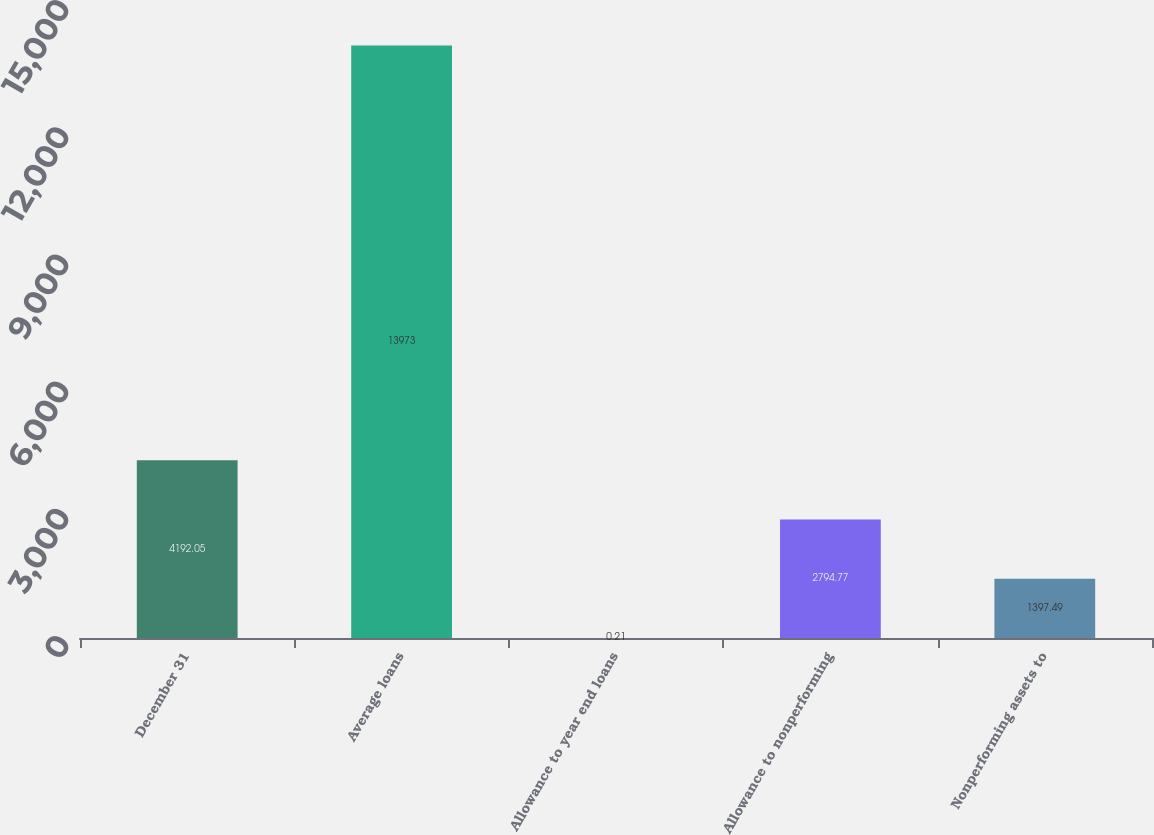Convert chart to OTSL. <chart><loc_0><loc_0><loc_500><loc_500><bar_chart><fcel>December 31<fcel>Average loans<fcel>Allowance to year end loans<fcel>Allowance to nonperforming<fcel>Nonperforming assets to<nl><fcel>4192.05<fcel>13973<fcel>0.21<fcel>2794.77<fcel>1397.49<nl></chart> 